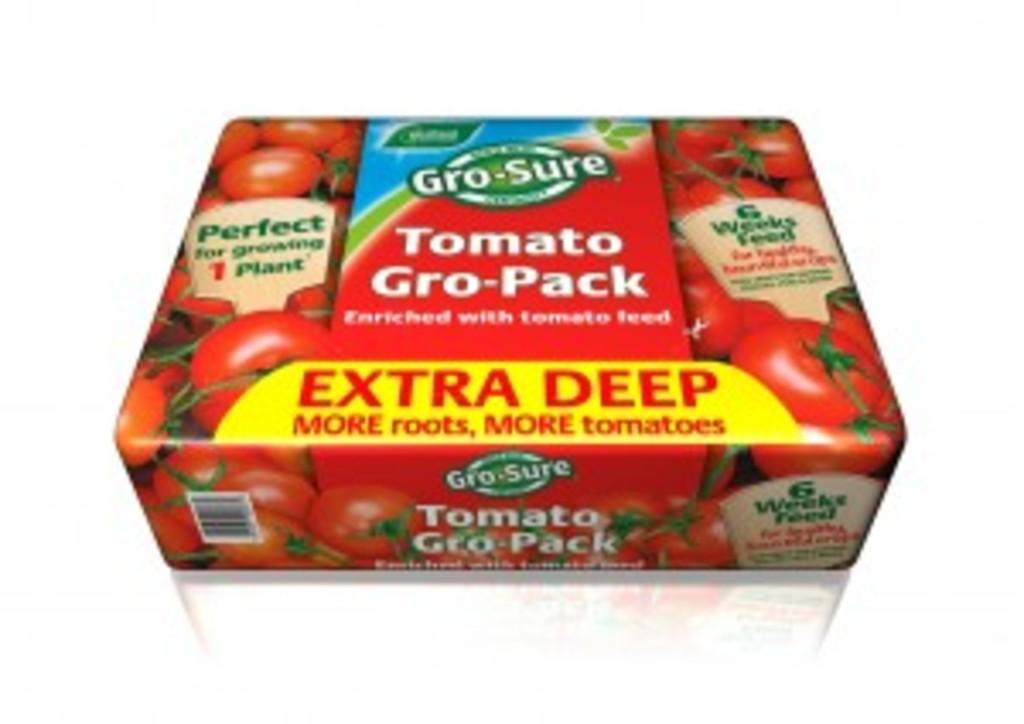What object can be seen in the image? There is a box in the image. What type of collar is the baby wearing in the image? There is no baby or collar present in the image; it only features a box. 